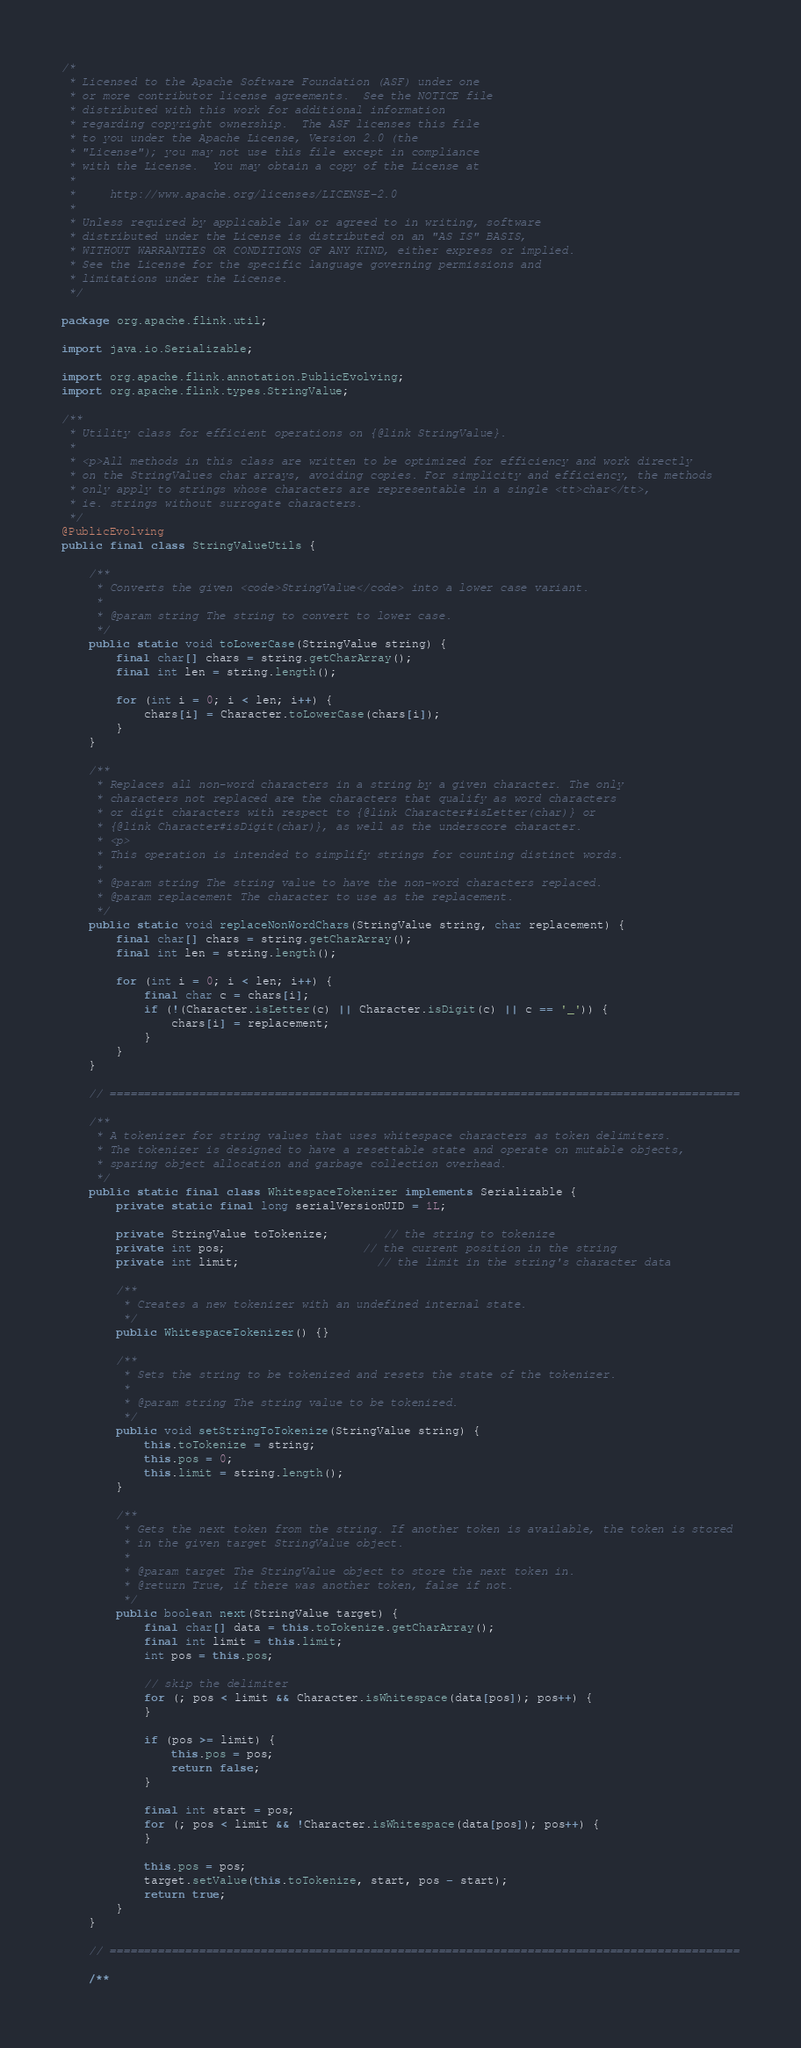<code> <loc_0><loc_0><loc_500><loc_500><_Java_>/*
 * Licensed to the Apache Software Foundation (ASF) under one
 * or more contributor license agreements.  See the NOTICE file
 * distributed with this work for additional information
 * regarding copyright ownership.  The ASF licenses this file
 * to you under the Apache License, Version 2.0 (the
 * "License"); you may not use this file except in compliance
 * with the License.  You may obtain a copy of the License at
 *
 *     http://www.apache.org/licenses/LICENSE-2.0
 *
 * Unless required by applicable law or agreed to in writing, software
 * distributed under the License is distributed on an "AS IS" BASIS,
 * WITHOUT WARRANTIES OR CONDITIONS OF ANY KIND, either express or implied.
 * See the License for the specific language governing permissions and
 * limitations under the License.
 */

package org.apache.flink.util;

import java.io.Serializable;

import org.apache.flink.annotation.PublicEvolving;
import org.apache.flink.types.StringValue;

/**
 * Utility class for efficient operations on {@link StringValue}.
 * 
 * <p>All methods in this class are written to be optimized for efficiency and work directly
 * on the StringValues char arrays, avoiding copies. For simplicity and efficiency, the methods
 * only apply to strings whose characters are representable in a single <tt>char</tt>,
 * ie. strings without surrogate characters.
 */
@PublicEvolving
public final class StringValueUtils {
	
	/**
	 * Converts the given <code>StringValue</code> into a lower case variant.
	 * 
	 * @param string The string to convert to lower case.
	 */
	public static void toLowerCase(StringValue string) {
		final char[] chars = string.getCharArray();
		final int len = string.length();
		
		for (int i = 0; i < len; i++) {
			chars[i] = Character.toLowerCase(chars[i]);
		}
	}
	
	/**
	 * Replaces all non-word characters in a string by a given character. The only
	 * characters not replaced are the characters that qualify as word characters
	 * or digit characters with respect to {@link Character#isLetter(char)} or
	 * {@link Character#isDigit(char)}, as well as the underscore character.
	 * <p>
	 * This operation is intended to simplify strings for counting distinct words.
	 * 
	 * @param string The string value to have the non-word characters replaced.
	 * @param replacement The character to use as the replacement.
	 */
	public static void replaceNonWordChars(StringValue string, char replacement) {
		final char[] chars = string.getCharArray();
		final int len = string.length();
		
		for (int i = 0; i < len; i++) {
			final char c = chars[i];
			if (!(Character.isLetter(c) || Character.isDigit(c) || c == '_')) {
				chars[i] = replacement;
			}
		}
	}
	
	// ============================================================================================
	
	/**
	 * A tokenizer for string values that uses whitespace characters as token delimiters.
	 * The tokenizer is designed to have a resettable state and operate on mutable objects,
	 * sparing object allocation and garbage collection overhead.
	 */
	public static final class WhitespaceTokenizer implements Serializable {
		private static final long serialVersionUID = 1L;
		
		private StringValue toTokenize;		// the string to tokenize
		private int pos;					// the current position in the string
		private int limit;					// the limit in the string's character data
		
		/**
		 * Creates a new tokenizer with an undefined internal state.
		 */
		public WhitespaceTokenizer() {}
		
		/**
		 * Sets the string to be tokenized and resets the state of the tokenizer.
		 * 
		 * @param string The string value to be tokenized.
		 */
		public void setStringToTokenize(StringValue string) {
			this.toTokenize = string;
			this.pos = 0;
			this.limit = string.length();
		}
		
		/**
		 * Gets the next token from the string. If another token is available, the token is stored
		 * in the given target StringValue object.
		 * 
		 * @param target The StringValue object to store the next token in.
		 * @return True, if there was another token, false if not.
		 */
		public boolean next(StringValue target) {
			final char[] data = this.toTokenize.getCharArray();
			final int limit = this.limit;
			int pos = this.pos;
			
			// skip the delimiter
			for (; pos < limit && Character.isWhitespace(data[pos]); pos++) {
			}
			
			if (pos >= limit) {
				this.pos = pos;
				return false;
			}
			
			final int start = pos;
			for (; pos < limit && !Character.isWhitespace(data[pos]); pos++) {
			}
			
			this.pos = pos;
			target.setValue(this.toTokenize, start, pos - start);
			return true;
		}
	}
	
	// ============================================================================================
	
	/**</code> 